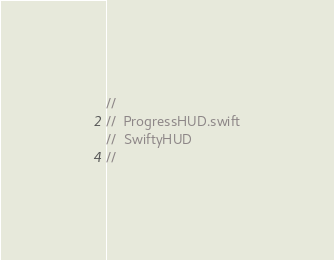<code> <loc_0><loc_0><loc_500><loc_500><_Swift_>//
//  ProgressHUD.swift
//  SwiftyHUD
//</code> 